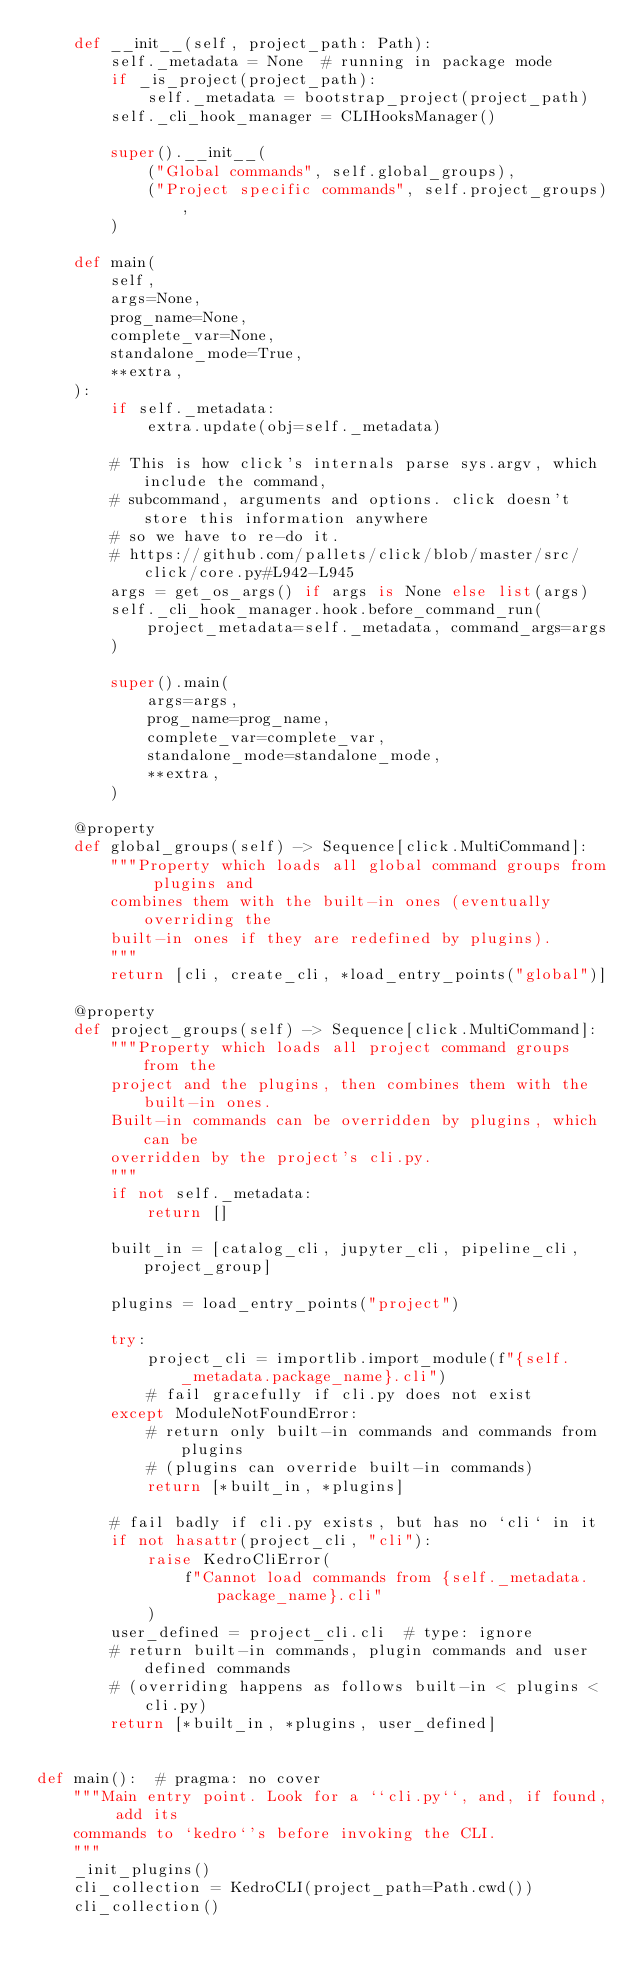<code> <loc_0><loc_0><loc_500><loc_500><_Python_>    def __init__(self, project_path: Path):
        self._metadata = None  # running in package mode
        if _is_project(project_path):
            self._metadata = bootstrap_project(project_path)
        self._cli_hook_manager = CLIHooksManager()

        super().__init__(
            ("Global commands", self.global_groups),
            ("Project specific commands", self.project_groups),
        )

    def main(
        self,
        args=None,
        prog_name=None,
        complete_var=None,
        standalone_mode=True,
        **extra,
    ):
        if self._metadata:
            extra.update(obj=self._metadata)

        # This is how click's internals parse sys.argv, which include the command,
        # subcommand, arguments and options. click doesn't store this information anywhere
        # so we have to re-do it.
        # https://github.com/pallets/click/blob/master/src/click/core.py#L942-L945
        args = get_os_args() if args is None else list(args)
        self._cli_hook_manager.hook.before_command_run(
            project_metadata=self._metadata, command_args=args
        )

        super().main(
            args=args,
            prog_name=prog_name,
            complete_var=complete_var,
            standalone_mode=standalone_mode,
            **extra,
        )

    @property
    def global_groups(self) -> Sequence[click.MultiCommand]:
        """Property which loads all global command groups from plugins and
        combines them with the built-in ones (eventually overriding the
        built-in ones if they are redefined by plugins).
        """
        return [cli, create_cli, *load_entry_points("global")]

    @property
    def project_groups(self) -> Sequence[click.MultiCommand]:
        """Property which loads all project command groups from the
        project and the plugins, then combines them with the built-in ones.
        Built-in commands can be overridden by plugins, which can be
        overridden by the project's cli.py.
        """
        if not self._metadata:
            return []

        built_in = [catalog_cli, jupyter_cli, pipeline_cli, project_group]

        plugins = load_entry_points("project")

        try:
            project_cli = importlib.import_module(f"{self._metadata.package_name}.cli")
            # fail gracefully if cli.py does not exist
        except ModuleNotFoundError:
            # return only built-in commands and commands from plugins
            # (plugins can override built-in commands)
            return [*built_in, *plugins]

        # fail badly if cli.py exists, but has no `cli` in it
        if not hasattr(project_cli, "cli"):
            raise KedroCliError(
                f"Cannot load commands from {self._metadata.package_name}.cli"
            )
        user_defined = project_cli.cli  # type: ignore
        # return built-in commands, plugin commands and user defined commands
        # (overriding happens as follows built-in < plugins < cli.py)
        return [*built_in, *plugins, user_defined]


def main():  # pragma: no cover
    """Main entry point. Look for a ``cli.py``, and, if found, add its
    commands to `kedro`'s before invoking the CLI.
    """
    _init_plugins()
    cli_collection = KedroCLI(project_path=Path.cwd())
    cli_collection()
</code> 